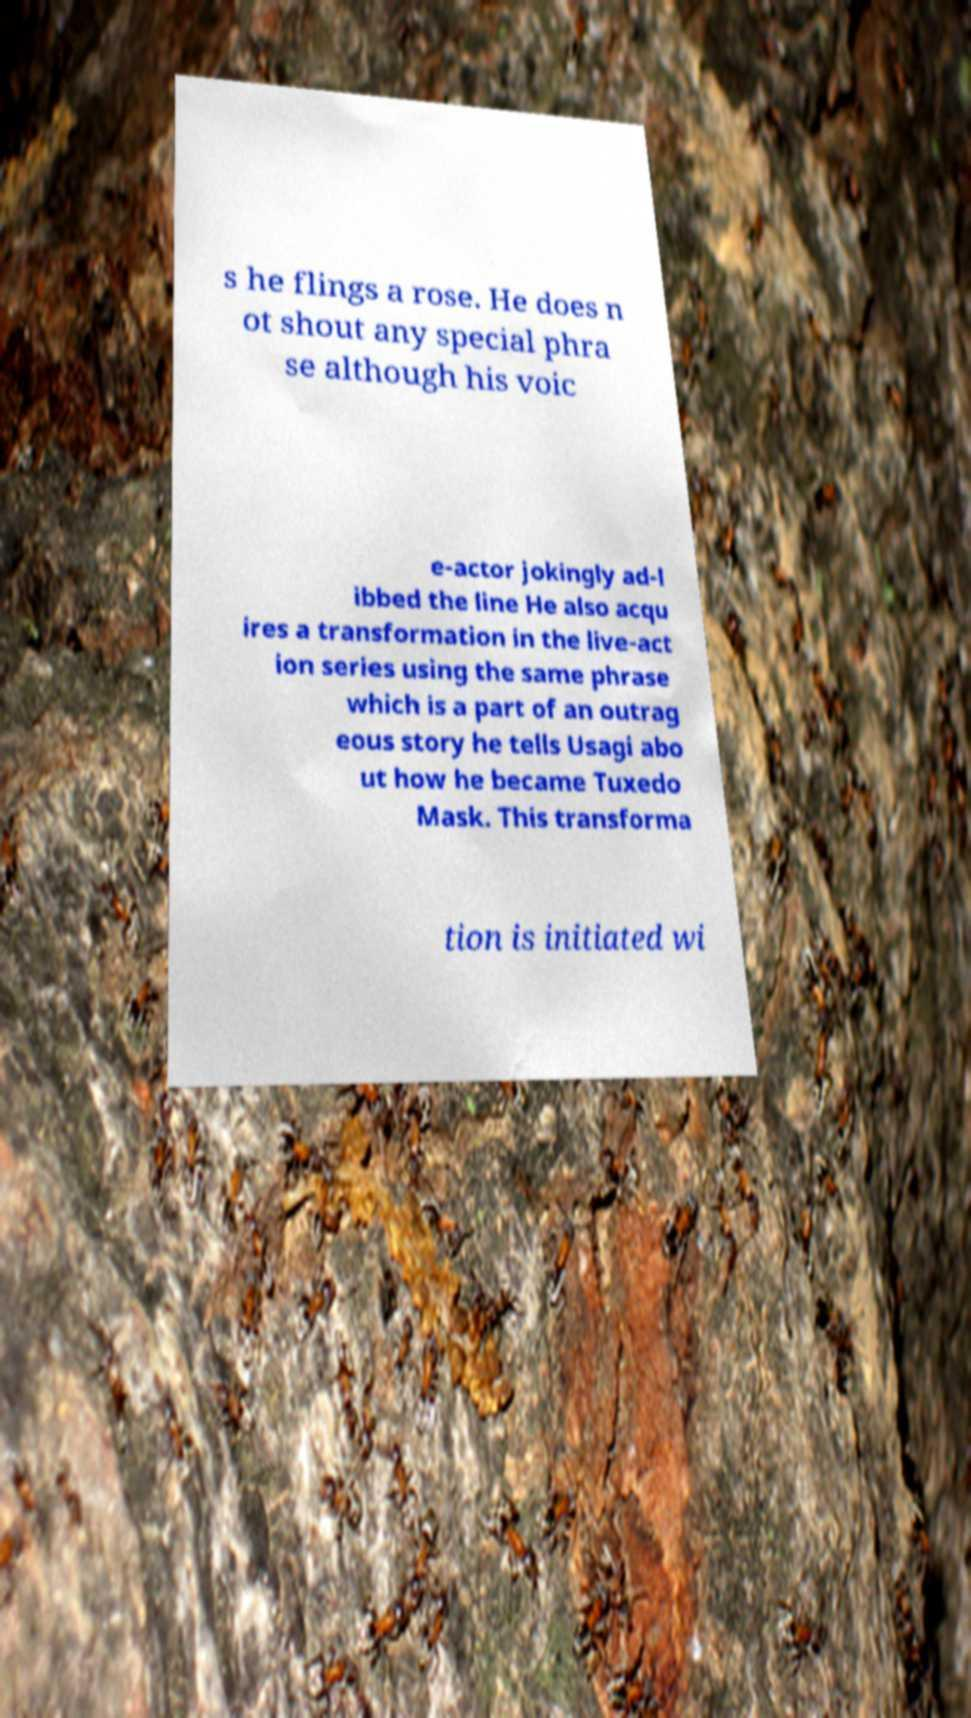For documentation purposes, I need the text within this image transcribed. Could you provide that? s he flings a rose. He does n ot shout any special phra se although his voic e-actor jokingly ad-l ibbed the line He also acqu ires a transformation in the live-act ion series using the same phrase which is a part of an outrag eous story he tells Usagi abo ut how he became Tuxedo Mask. This transforma tion is initiated wi 